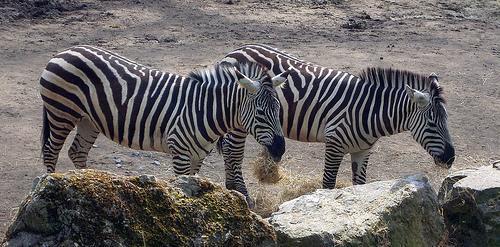How many zebras are there?
Give a very brief answer. 2. 